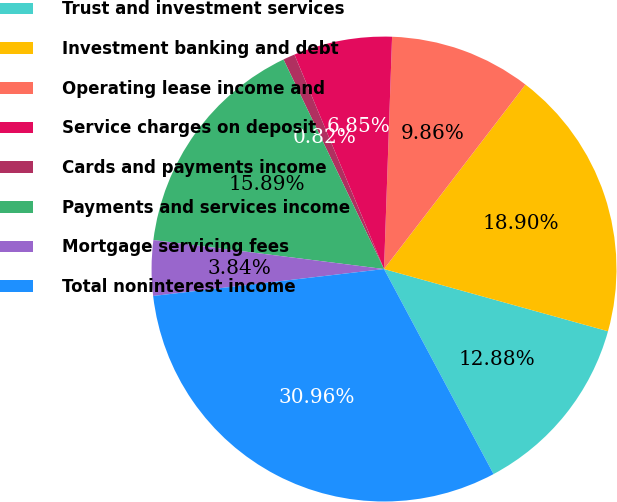<chart> <loc_0><loc_0><loc_500><loc_500><pie_chart><fcel>Trust and investment services<fcel>Investment banking and debt<fcel>Operating lease income and<fcel>Service charges on deposit<fcel>Cards and payments income<fcel>Payments and services income<fcel>Mortgage servicing fees<fcel>Total noninterest income<nl><fcel>12.88%<fcel>18.9%<fcel>9.86%<fcel>6.85%<fcel>0.82%<fcel>15.89%<fcel>3.84%<fcel>30.96%<nl></chart> 